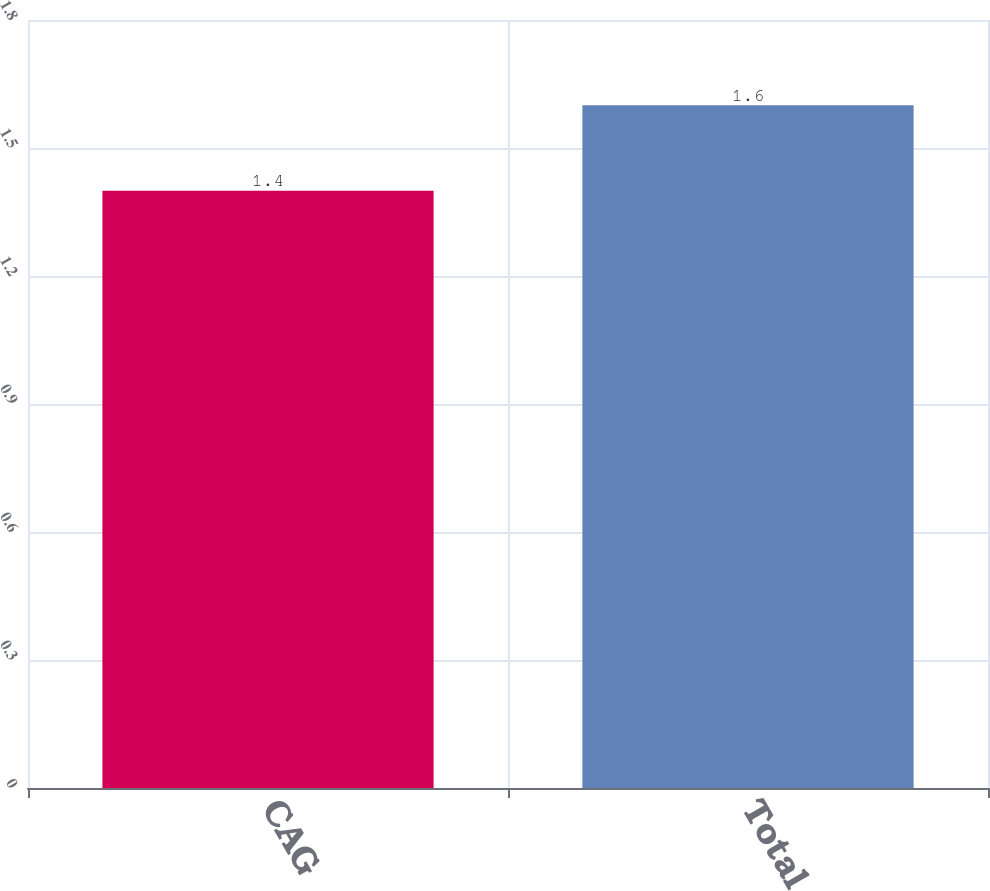Convert chart to OTSL. <chart><loc_0><loc_0><loc_500><loc_500><bar_chart><fcel>CAG<fcel>Total<nl><fcel>1.4<fcel>1.6<nl></chart> 